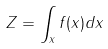<formula> <loc_0><loc_0><loc_500><loc_500>Z = \int _ { x } f ( x ) d x</formula> 